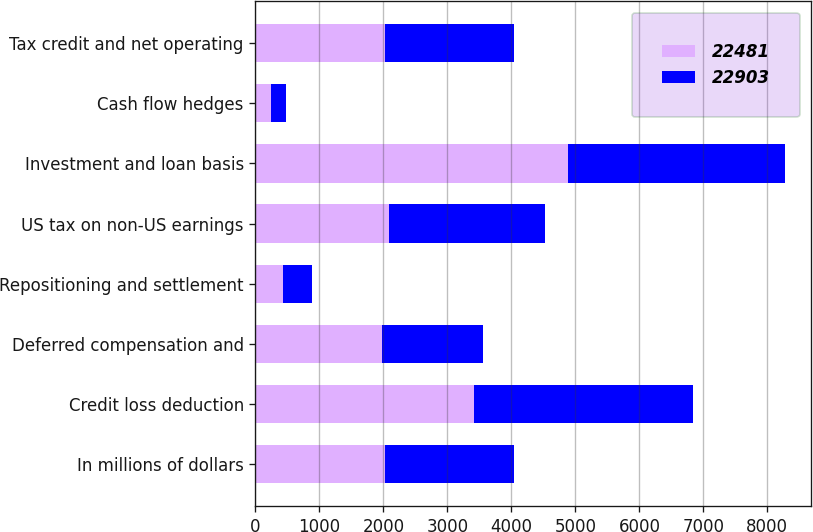<chart> <loc_0><loc_0><loc_500><loc_500><stacked_bar_chart><ecel><fcel>In millions of dollars<fcel>Credit loss deduction<fcel>Deferred compensation and<fcel>Repositioning and settlement<fcel>US tax on non-US earnings<fcel>Investment and loan basis<fcel>Cash flow hedges<fcel>Tax credit and net operating<nl><fcel>22481<fcel>2018<fcel>3419<fcel>1975<fcel>428<fcel>2080<fcel>4891<fcel>240<fcel>2017.5<nl><fcel>22903<fcel>2017<fcel>3423<fcel>1585<fcel>454<fcel>2452<fcel>3384<fcel>233<fcel>2017.5<nl></chart> 